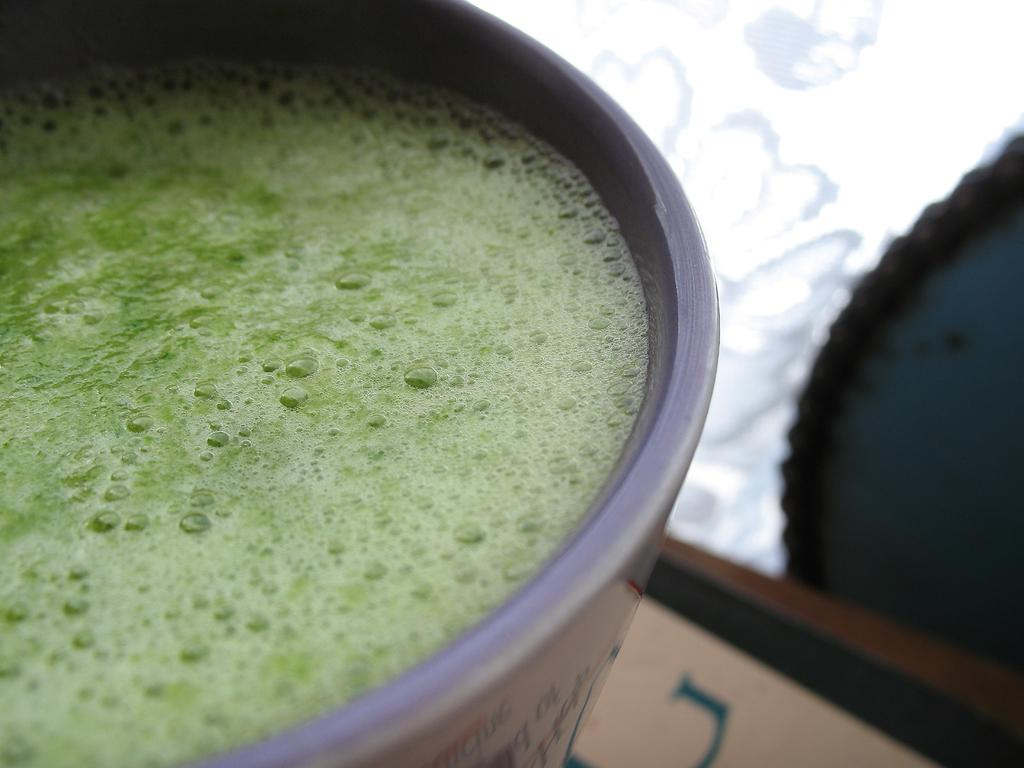What is the condition of the cup in the image? The cup in the image is truncated. What is inside the cup? There is juice in the cup. What color is the background of the image? The background of the image is white. What type of glue is being used to hold the cup together in the image? There is no glue present in the image, and the cup is not being held together; it is truncated. Is there a crook in the image trying to steal the cup? There is no crook present in the image, and the cup is not being stolen. 